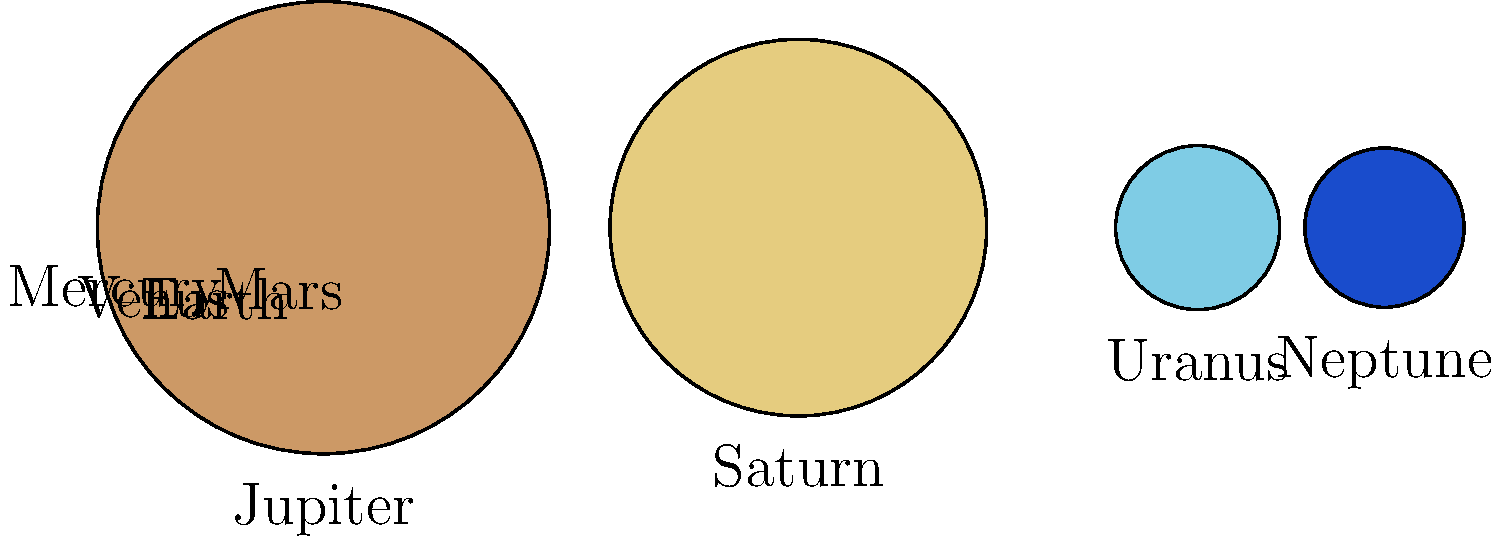Looking at this diagram of our solar system's planets, which two planets appear to be the most similar in size? To answer this question, let's follow these steps:

1. Observe the relative sizes of the planets in the diagram.
2. The planets are arranged in order from left to right: Mercury, Venus, Earth, Mars, Jupiter, Saturn, Uranus, and Neptune.
3. Jupiter and Saturn are clearly the largest.
4. Mercury and Mars are the smallest.
5. Earth and Venus appear very close in size.
6. Uranus and Neptune also look very similar in size.
7. Comparing Earth-Venus to Uranus-Neptune, we can see that Uranus and Neptune are larger but even closer in size to each other.

Therefore, Uranus and Neptune appear to be the most similar in size based on this diagram.

In reality, Uranus has a diameter of 50,724 km, while Neptune's diameter is 49,244 km. This small difference of only 1,480 km (about 3%) makes them indeed the most similar in size among the planets in our solar system.
Answer: Uranus and Neptune 